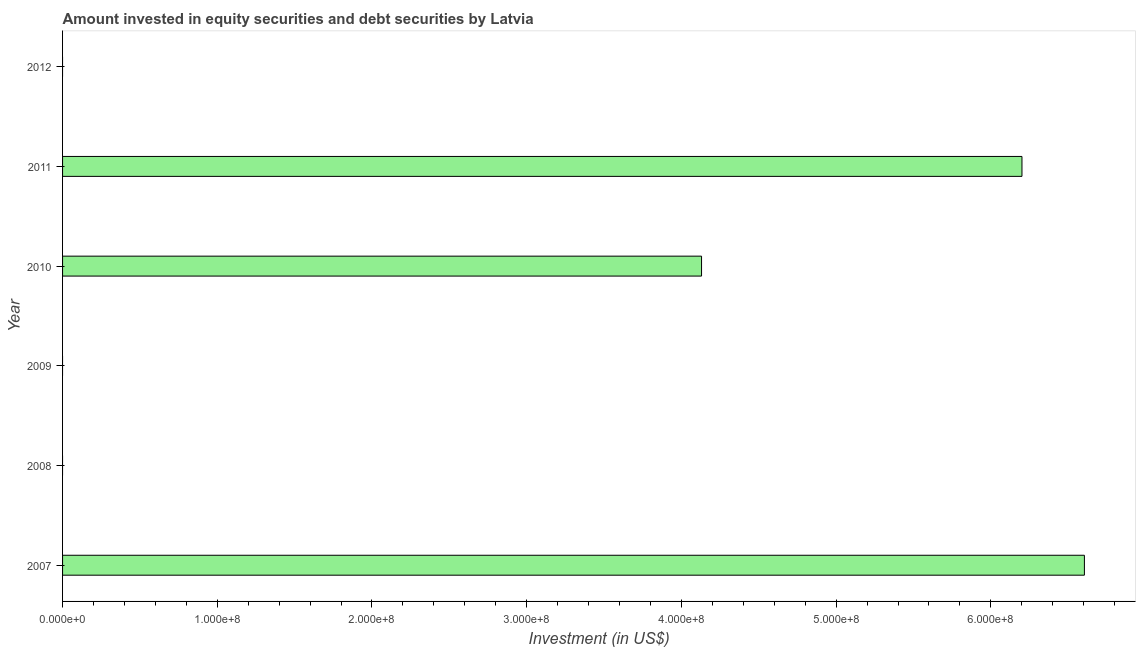Does the graph contain any zero values?
Your answer should be compact. Yes. Does the graph contain grids?
Offer a terse response. No. What is the title of the graph?
Provide a succinct answer. Amount invested in equity securities and debt securities by Latvia. What is the label or title of the X-axis?
Offer a terse response. Investment (in US$). Across all years, what is the maximum portfolio investment?
Provide a succinct answer. 6.60e+08. What is the sum of the portfolio investment?
Provide a short and direct response. 1.69e+09. What is the difference between the portfolio investment in 2007 and 2011?
Give a very brief answer. 4.03e+07. What is the average portfolio investment per year?
Make the answer very short. 2.82e+08. What is the median portfolio investment?
Make the answer very short. 2.07e+08. What is the ratio of the portfolio investment in 2007 to that in 2011?
Your answer should be compact. 1.06. Is the portfolio investment in 2007 less than that in 2010?
Provide a short and direct response. No. Is the difference between the portfolio investment in 2007 and 2010 greater than the difference between any two years?
Ensure brevity in your answer.  No. What is the difference between the highest and the second highest portfolio investment?
Your answer should be compact. 4.03e+07. What is the difference between the highest and the lowest portfolio investment?
Your response must be concise. 6.60e+08. What is the difference between two consecutive major ticks on the X-axis?
Keep it short and to the point. 1.00e+08. What is the Investment (in US$) in 2007?
Offer a very short reply. 6.60e+08. What is the Investment (in US$) in 2010?
Make the answer very short. 4.13e+08. What is the Investment (in US$) in 2011?
Provide a succinct answer. 6.20e+08. What is the difference between the Investment (in US$) in 2007 and 2010?
Your answer should be very brief. 2.47e+08. What is the difference between the Investment (in US$) in 2007 and 2011?
Offer a terse response. 4.03e+07. What is the difference between the Investment (in US$) in 2010 and 2011?
Your answer should be compact. -2.07e+08. What is the ratio of the Investment (in US$) in 2007 to that in 2010?
Offer a terse response. 1.6. What is the ratio of the Investment (in US$) in 2007 to that in 2011?
Give a very brief answer. 1.06. What is the ratio of the Investment (in US$) in 2010 to that in 2011?
Offer a terse response. 0.67. 